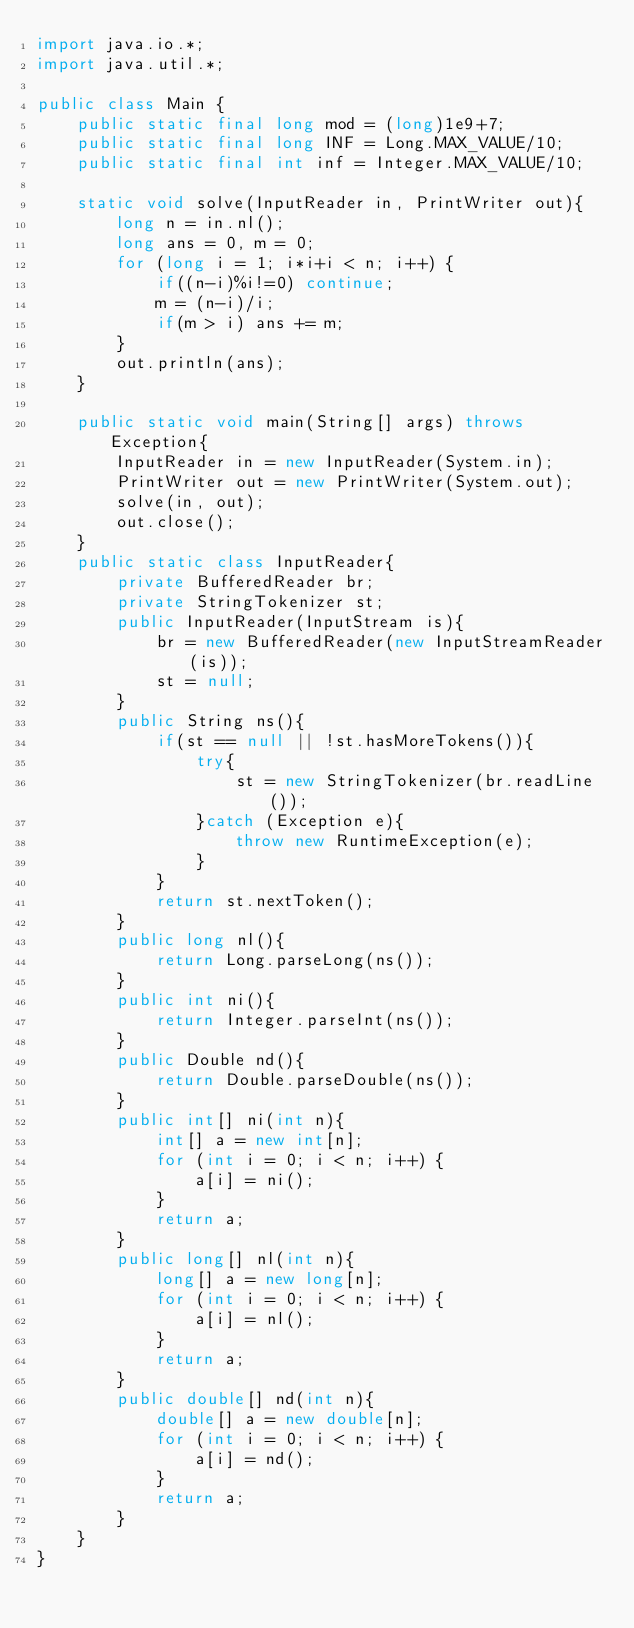<code> <loc_0><loc_0><loc_500><loc_500><_Java_>import java.io.*;
import java.util.*;

public class Main {
    public static final long mod = (long)1e9+7;
    public static final long INF = Long.MAX_VALUE/10;
    public static final int inf = Integer.MAX_VALUE/10;

    static void solve(InputReader in, PrintWriter out){
        long n = in.nl();
        long ans = 0, m = 0;
        for (long i = 1; i*i+i < n; i++) {
            if((n-i)%i!=0) continue;
            m = (n-i)/i;
            if(m > i) ans += m;
        }
        out.println(ans);
    }

    public static void main(String[] args) throws Exception{
        InputReader in = new InputReader(System.in);
        PrintWriter out = new PrintWriter(System.out);
        solve(in, out);
        out.close();
    }
    public static class InputReader{
        private BufferedReader br;
        private StringTokenizer st;
        public InputReader(InputStream is){
            br = new BufferedReader(new InputStreamReader(is));
            st = null;
        }
        public String ns(){
            if(st == null || !st.hasMoreTokens()){
                try{
                    st = new StringTokenizer(br.readLine());
                }catch (Exception e){
                    throw new RuntimeException(e);
                }
            }
            return st.nextToken();
        }
        public long nl(){
            return Long.parseLong(ns());
        }
        public int ni(){
            return Integer.parseInt(ns());
        }
        public Double nd(){
            return Double.parseDouble(ns());
        }
        public int[] ni(int n){
            int[] a = new int[n];
            for (int i = 0; i < n; i++) {
                a[i] = ni();
            }
            return a;
        }
        public long[] nl(int n){
            long[] a = new long[n];
            for (int i = 0; i < n; i++) {
                a[i] = nl();
            }
            return a;
        }
        public double[] nd(int n){
            double[] a = new double[n];
            for (int i = 0; i < n; i++) {
                a[i] = nd();
            }
            return a;
        }
    }
}</code> 